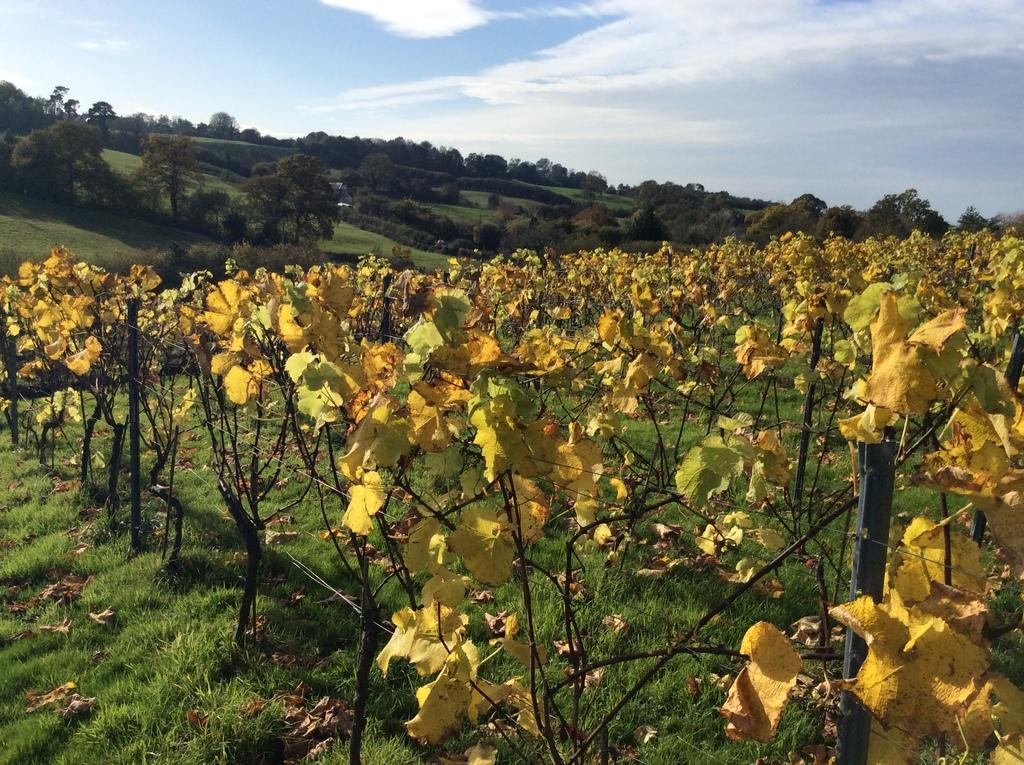What can be seen in the foreground of the picture? In the foreground of the picture, there are plants, grass, and dry leaves. What is visible in the background of the picture? In the background of the picture, there are trees and grasslands. What part of the natural environment is visible at the top of the picture? The sky is visible at the top of the picture. What type of mine can be seen in the background of the picture? There is no mine present in the picture; it features plants, grass, dry leaves, trees, grasslands, and the sky. Can you tell me how many attempts were made to write on the dry leaves in the picture? There is no writing or attempts to write on the dry leaves in the picture. 